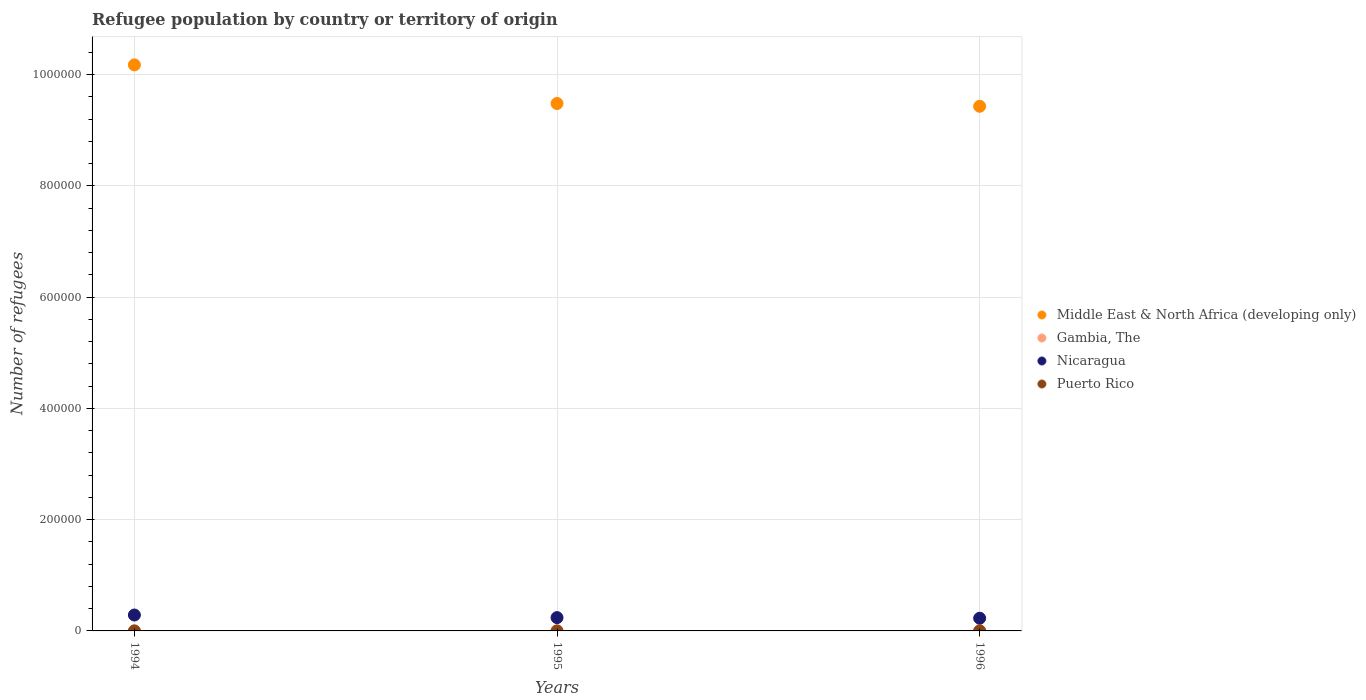What is the number of refugees in Nicaragua in 1995?
Offer a very short reply. 2.39e+04. Across all years, what is the maximum number of refugees in Gambia, The?
Keep it short and to the point. 310. Across all years, what is the minimum number of refugees in Middle East & North Africa (developing only)?
Provide a succinct answer. 9.43e+05. What is the total number of refugees in Gambia, The in the graph?
Your answer should be compact. 501. What is the difference between the number of refugees in Nicaragua in 1994 and that in 1995?
Give a very brief answer. 4653. What is the difference between the number of refugees in Middle East & North Africa (developing only) in 1995 and the number of refugees in Gambia, The in 1996?
Give a very brief answer. 9.48e+05. What is the average number of refugees in Gambia, The per year?
Make the answer very short. 167. In the year 1996, what is the difference between the number of refugees in Nicaragua and number of refugees in Puerto Rico?
Ensure brevity in your answer.  2.28e+04. In how many years, is the number of refugees in Gambia, The greater than 440000?
Provide a short and direct response. 0. What is the ratio of the number of refugees in Middle East & North Africa (developing only) in 1995 to that in 1996?
Offer a terse response. 1.01. Is the number of refugees in Puerto Rico in 1994 less than that in 1995?
Your response must be concise. No. Is the difference between the number of refugees in Nicaragua in 1995 and 1996 greater than the difference between the number of refugees in Puerto Rico in 1995 and 1996?
Your answer should be very brief. Yes. What is the difference between the highest and the second highest number of refugees in Nicaragua?
Offer a very short reply. 4653. What is the difference between the highest and the lowest number of refugees in Gambia, The?
Give a very brief answer. 280. Is the sum of the number of refugees in Puerto Rico in 1994 and 1996 greater than the maximum number of refugees in Gambia, The across all years?
Give a very brief answer. No. Is it the case that in every year, the sum of the number of refugees in Nicaragua and number of refugees in Middle East & North Africa (developing only)  is greater than the number of refugees in Gambia, The?
Provide a succinct answer. Yes. Is the number of refugees in Puerto Rico strictly less than the number of refugees in Nicaragua over the years?
Keep it short and to the point. Yes. What is the difference between two consecutive major ticks on the Y-axis?
Provide a succinct answer. 2.00e+05. Does the graph contain any zero values?
Your answer should be compact. No. What is the title of the graph?
Offer a very short reply. Refugee population by country or territory of origin. Does "Macao" appear as one of the legend labels in the graph?
Make the answer very short. No. What is the label or title of the Y-axis?
Offer a terse response. Number of refugees. What is the Number of refugees in Middle East & North Africa (developing only) in 1994?
Make the answer very short. 1.02e+06. What is the Number of refugees in Gambia, The in 1994?
Make the answer very short. 30. What is the Number of refugees of Nicaragua in 1994?
Give a very brief answer. 2.86e+04. What is the Number of refugees in Middle East & North Africa (developing only) in 1995?
Offer a terse response. 9.48e+05. What is the Number of refugees in Gambia, The in 1995?
Give a very brief answer. 161. What is the Number of refugees in Nicaragua in 1995?
Give a very brief answer. 2.39e+04. What is the Number of refugees in Puerto Rico in 1995?
Provide a succinct answer. 12. What is the Number of refugees of Middle East & North Africa (developing only) in 1996?
Offer a terse response. 9.43e+05. What is the Number of refugees of Gambia, The in 1996?
Ensure brevity in your answer.  310. What is the Number of refugees of Nicaragua in 1996?
Make the answer very short. 2.28e+04. What is the Number of refugees in Puerto Rico in 1996?
Provide a short and direct response. 12. Across all years, what is the maximum Number of refugees of Middle East & North Africa (developing only)?
Provide a short and direct response. 1.02e+06. Across all years, what is the maximum Number of refugees in Gambia, The?
Offer a very short reply. 310. Across all years, what is the maximum Number of refugees in Nicaragua?
Your answer should be very brief. 2.86e+04. Across all years, what is the minimum Number of refugees of Middle East & North Africa (developing only)?
Ensure brevity in your answer.  9.43e+05. Across all years, what is the minimum Number of refugees in Gambia, The?
Ensure brevity in your answer.  30. Across all years, what is the minimum Number of refugees in Nicaragua?
Make the answer very short. 2.28e+04. Across all years, what is the minimum Number of refugees in Puerto Rico?
Your response must be concise. 12. What is the total Number of refugees of Middle East & North Africa (developing only) in the graph?
Make the answer very short. 2.91e+06. What is the total Number of refugees of Gambia, The in the graph?
Your answer should be very brief. 501. What is the total Number of refugees in Nicaragua in the graph?
Offer a terse response. 7.53e+04. What is the difference between the Number of refugees of Middle East & North Africa (developing only) in 1994 and that in 1995?
Give a very brief answer. 6.94e+04. What is the difference between the Number of refugees in Gambia, The in 1994 and that in 1995?
Give a very brief answer. -131. What is the difference between the Number of refugees of Nicaragua in 1994 and that in 1995?
Offer a terse response. 4653. What is the difference between the Number of refugees in Middle East & North Africa (developing only) in 1994 and that in 1996?
Ensure brevity in your answer.  7.44e+04. What is the difference between the Number of refugees of Gambia, The in 1994 and that in 1996?
Your answer should be compact. -280. What is the difference between the Number of refugees in Nicaragua in 1994 and that in 1996?
Give a very brief answer. 5771. What is the difference between the Number of refugees in Middle East & North Africa (developing only) in 1995 and that in 1996?
Make the answer very short. 5018. What is the difference between the Number of refugees in Gambia, The in 1995 and that in 1996?
Offer a very short reply. -149. What is the difference between the Number of refugees in Nicaragua in 1995 and that in 1996?
Your response must be concise. 1118. What is the difference between the Number of refugees in Middle East & North Africa (developing only) in 1994 and the Number of refugees in Gambia, The in 1995?
Provide a short and direct response. 1.02e+06. What is the difference between the Number of refugees of Middle East & North Africa (developing only) in 1994 and the Number of refugees of Nicaragua in 1995?
Your answer should be very brief. 9.93e+05. What is the difference between the Number of refugees in Middle East & North Africa (developing only) in 1994 and the Number of refugees in Puerto Rico in 1995?
Provide a succinct answer. 1.02e+06. What is the difference between the Number of refugees of Gambia, The in 1994 and the Number of refugees of Nicaragua in 1995?
Make the answer very short. -2.39e+04. What is the difference between the Number of refugees in Gambia, The in 1994 and the Number of refugees in Puerto Rico in 1995?
Your answer should be very brief. 18. What is the difference between the Number of refugees of Nicaragua in 1994 and the Number of refugees of Puerto Rico in 1995?
Your response must be concise. 2.86e+04. What is the difference between the Number of refugees in Middle East & North Africa (developing only) in 1994 and the Number of refugees in Gambia, The in 1996?
Ensure brevity in your answer.  1.02e+06. What is the difference between the Number of refugees in Middle East & North Africa (developing only) in 1994 and the Number of refugees in Nicaragua in 1996?
Make the answer very short. 9.95e+05. What is the difference between the Number of refugees of Middle East & North Africa (developing only) in 1994 and the Number of refugees of Puerto Rico in 1996?
Offer a terse response. 1.02e+06. What is the difference between the Number of refugees in Gambia, The in 1994 and the Number of refugees in Nicaragua in 1996?
Provide a succinct answer. -2.28e+04. What is the difference between the Number of refugees in Nicaragua in 1994 and the Number of refugees in Puerto Rico in 1996?
Your response must be concise. 2.86e+04. What is the difference between the Number of refugees in Middle East & North Africa (developing only) in 1995 and the Number of refugees in Gambia, The in 1996?
Give a very brief answer. 9.48e+05. What is the difference between the Number of refugees in Middle East & North Africa (developing only) in 1995 and the Number of refugees in Nicaragua in 1996?
Provide a short and direct response. 9.25e+05. What is the difference between the Number of refugees in Middle East & North Africa (developing only) in 1995 and the Number of refugees in Puerto Rico in 1996?
Your answer should be very brief. 9.48e+05. What is the difference between the Number of refugees in Gambia, The in 1995 and the Number of refugees in Nicaragua in 1996?
Your response must be concise. -2.27e+04. What is the difference between the Number of refugees in Gambia, The in 1995 and the Number of refugees in Puerto Rico in 1996?
Keep it short and to the point. 149. What is the difference between the Number of refugees in Nicaragua in 1995 and the Number of refugees in Puerto Rico in 1996?
Your answer should be very brief. 2.39e+04. What is the average Number of refugees of Middle East & North Africa (developing only) per year?
Ensure brevity in your answer.  9.69e+05. What is the average Number of refugees in Gambia, The per year?
Provide a succinct answer. 167. What is the average Number of refugees of Nicaragua per year?
Provide a succinct answer. 2.51e+04. What is the average Number of refugees in Puerto Rico per year?
Provide a succinct answer. 12. In the year 1994, what is the difference between the Number of refugees in Middle East & North Africa (developing only) and Number of refugees in Gambia, The?
Your answer should be very brief. 1.02e+06. In the year 1994, what is the difference between the Number of refugees in Middle East & North Africa (developing only) and Number of refugees in Nicaragua?
Ensure brevity in your answer.  9.89e+05. In the year 1994, what is the difference between the Number of refugees of Middle East & North Africa (developing only) and Number of refugees of Puerto Rico?
Your response must be concise. 1.02e+06. In the year 1994, what is the difference between the Number of refugees in Gambia, The and Number of refugees in Nicaragua?
Your answer should be compact. -2.86e+04. In the year 1994, what is the difference between the Number of refugees in Gambia, The and Number of refugees in Puerto Rico?
Ensure brevity in your answer.  18. In the year 1994, what is the difference between the Number of refugees in Nicaragua and Number of refugees in Puerto Rico?
Make the answer very short. 2.86e+04. In the year 1995, what is the difference between the Number of refugees of Middle East & North Africa (developing only) and Number of refugees of Gambia, The?
Ensure brevity in your answer.  9.48e+05. In the year 1995, what is the difference between the Number of refugees of Middle East & North Africa (developing only) and Number of refugees of Nicaragua?
Provide a short and direct response. 9.24e+05. In the year 1995, what is the difference between the Number of refugees of Middle East & North Africa (developing only) and Number of refugees of Puerto Rico?
Provide a short and direct response. 9.48e+05. In the year 1995, what is the difference between the Number of refugees in Gambia, The and Number of refugees in Nicaragua?
Your answer should be compact. -2.38e+04. In the year 1995, what is the difference between the Number of refugees in Gambia, The and Number of refugees in Puerto Rico?
Keep it short and to the point. 149. In the year 1995, what is the difference between the Number of refugees of Nicaragua and Number of refugees of Puerto Rico?
Your response must be concise. 2.39e+04. In the year 1996, what is the difference between the Number of refugees of Middle East & North Africa (developing only) and Number of refugees of Gambia, The?
Your answer should be compact. 9.43e+05. In the year 1996, what is the difference between the Number of refugees in Middle East & North Africa (developing only) and Number of refugees in Nicaragua?
Offer a very short reply. 9.20e+05. In the year 1996, what is the difference between the Number of refugees in Middle East & North Africa (developing only) and Number of refugees in Puerto Rico?
Ensure brevity in your answer.  9.43e+05. In the year 1996, what is the difference between the Number of refugees of Gambia, The and Number of refugees of Nicaragua?
Provide a succinct answer. -2.25e+04. In the year 1996, what is the difference between the Number of refugees of Gambia, The and Number of refugees of Puerto Rico?
Your answer should be compact. 298. In the year 1996, what is the difference between the Number of refugees in Nicaragua and Number of refugees in Puerto Rico?
Make the answer very short. 2.28e+04. What is the ratio of the Number of refugees of Middle East & North Africa (developing only) in 1994 to that in 1995?
Ensure brevity in your answer.  1.07. What is the ratio of the Number of refugees in Gambia, The in 1994 to that in 1995?
Provide a short and direct response. 0.19. What is the ratio of the Number of refugees in Nicaragua in 1994 to that in 1995?
Give a very brief answer. 1.19. What is the ratio of the Number of refugees in Middle East & North Africa (developing only) in 1994 to that in 1996?
Keep it short and to the point. 1.08. What is the ratio of the Number of refugees of Gambia, The in 1994 to that in 1996?
Make the answer very short. 0.1. What is the ratio of the Number of refugees in Nicaragua in 1994 to that in 1996?
Offer a terse response. 1.25. What is the ratio of the Number of refugees in Puerto Rico in 1994 to that in 1996?
Offer a very short reply. 1. What is the ratio of the Number of refugees in Gambia, The in 1995 to that in 1996?
Provide a short and direct response. 0.52. What is the ratio of the Number of refugees in Nicaragua in 1995 to that in 1996?
Keep it short and to the point. 1.05. What is the difference between the highest and the second highest Number of refugees in Middle East & North Africa (developing only)?
Provide a short and direct response. 6.94e+04. What is the difference between the highest and the second highest Number of refugees in Gambia, The?
Ensure brevity in your answer.  149. What is the difference between the highest and the second highest Number of refugees in Nicaragua?
Make the answer very short. 4653. What is the difference between the highest and the lowest Number of refugees of Middle East & North Africa (developing only)?
Your response must be concise. 7.44e+04. What is the difference between the highest and the lowest Number of refugees of Gambia, The?
Make the answer very short. 280. What is the difference between the highest and the lowest Number of refugees of Nicaragua?
Provide a succinct answer. 5771. 